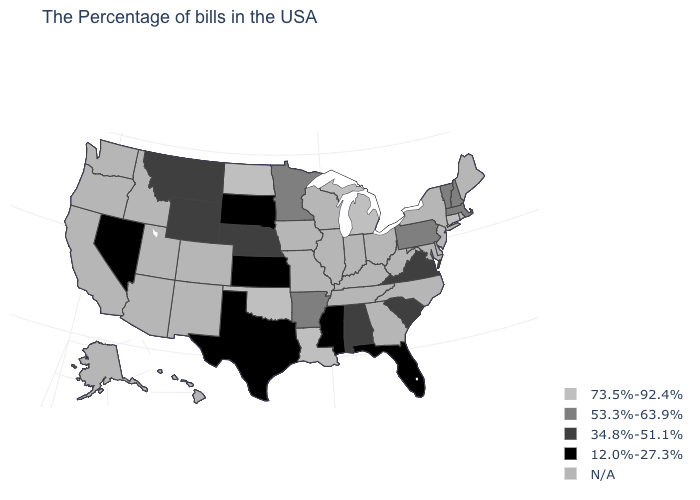What is the value of Idaho?
Write a very short answer. N/A. Which states have the lowest value in the USA?
Give a very brief answer. Florida, Mississippi, Kansas, Texas, South Dakota, Nevada. What is the value of Ohio?
Answer briefly. N/A. Which states have the lowest value in the Northeast?
Be succinct. Massachusetts, New Hampshire, Vermont, Pennsylvania. What is the value of Kansas?
Short answer required. 12.0%-27.3%. Does Florida have the lowest value in the USA?
Quick response, please. Yes. Which states hav the highest value in the South?
Be succinct. Louisiana, Oklahoma. Name the states that have a value in the range N/A?
Quick response, please. Maine, Rhode Island, New York, New Jersey, Delaware, Maryland, North Carolina, West Virginia, Ohio, Georgia, Kentucky, Indiana, Tennessee, Wisconsin, Illinois, Missouri, Iowa, Colorado, New Mexico, Utah, Arizona, Idaho, California, Washington, Oregon, Alaska, Hawaii. What is the highest value in the USA?
Be succinct. 73.5%-92.4%. Among the states that border Louisiana , does Mississippi have the lowest value?
Short answer required. Yes. Name the states that have a value in the range 73.5%-92.4%?
Answer briefly. Connecticut, Michigan, Louisiana, Oklahoma, North Dakota. Does the first symbol in the legend represent the smallest category?
Concise answer only. No. Name the states that have a value in the range N/A?
Quick response, please. Maine, Rhode Island, New York, New Jersey, Delaware, Maryland, North Carolina, West Virginia, Ohio, Georgia, Kentucky, Indiana, Tennessee, Wisconsin, Illinois, Missouri, Iowa, Colorado, New Mexico, Utah, Arizona, Idaho, California, Washington, Oregon, Alaska, Hawaii. Name the states that have a value in the range 12.0%-27.3%?
Quick response, please. Florida, Mississippi, Kansas, Texas, South Dakota, Nevada. 